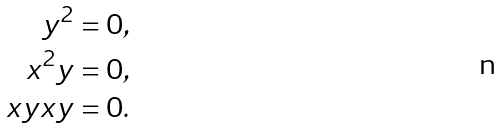<formula> <loc_0><loc_0><loc_500><loc_500>y ^ { 2 } = 0 , \\ x ^ { 2 } y = 0 , \\ x y x y = 0 .</formula> 